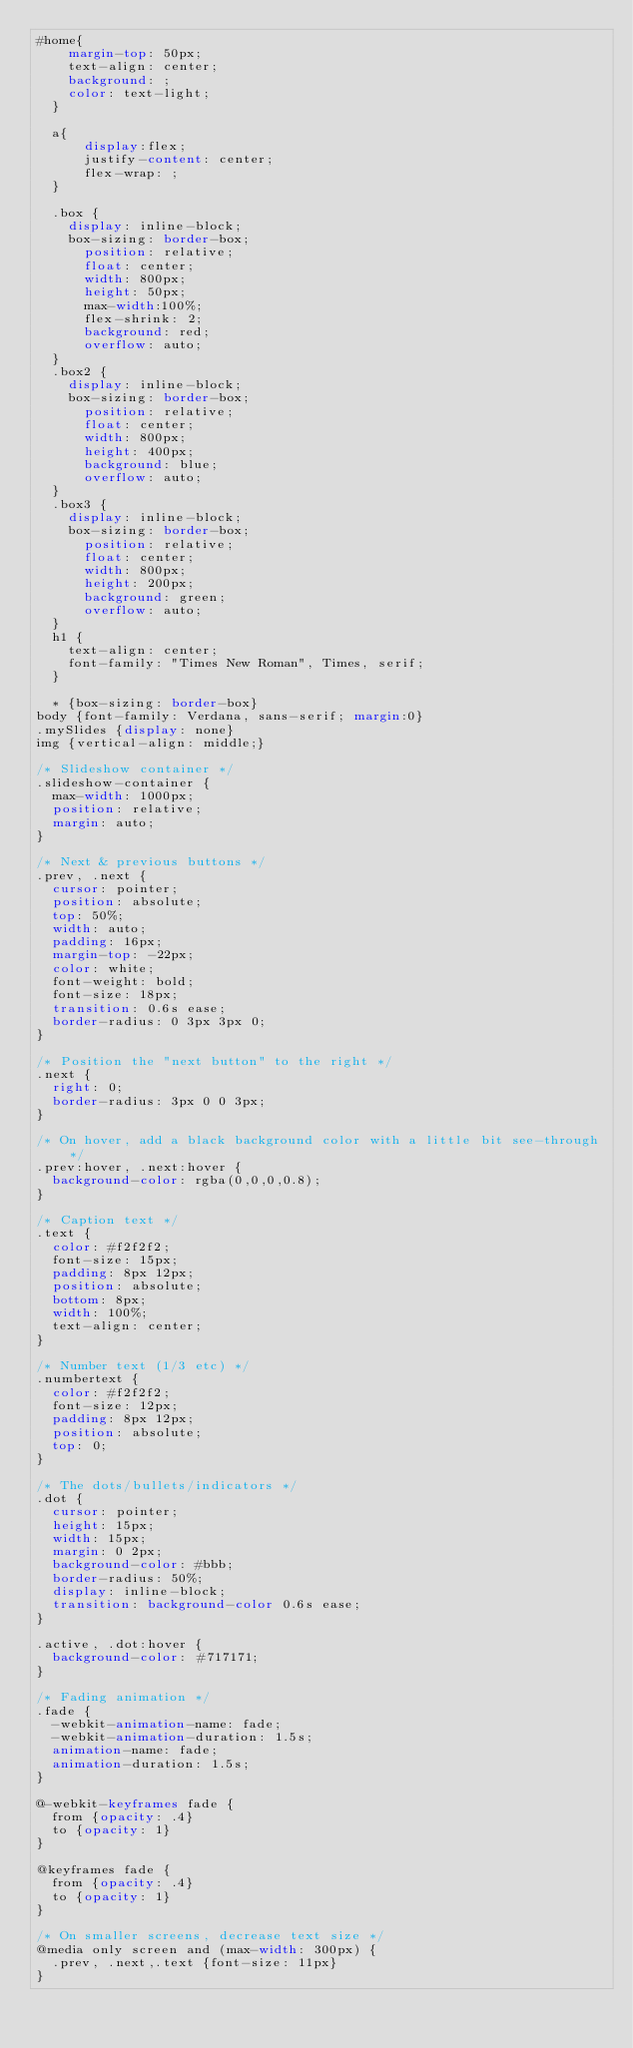Convert code to text. <code><loc_0><loc_0><loc_500><loc_500><_CSS_>#home{
    margin-top: 50px;
    text-align: center;
    background: ;
    color: text-light;
  }
  
  a{
      display:flex;
      justify-content: center;
      flex-wrap: ;
  }
  
  .box {
    display: inline-block;
    box-sizing: border-box;
      position: relative;
      float: center;
      width: 800px;
      height: 50px;
      max-width:100%;
      flex-shrink: 2;
      background: red; 
      overflow: auto;
  }
  .box2 {
    display: inline-block;
    box-sizing: border-box;
      position: relative;
      float: center;
      width: 800px;
      height: 400px;
      background: blue; 
      overflow: auto;
  }
  .box3 {
    display: inline-block;
    box-sizing: border-box;
      position: relative;
      float: center;
      width: 800px;
      height: 200px;
      background: green;
      overflow: auto;
  }
  h1 {
    text-align: center;
    font-family: "Times New Roman", Times, serif;
  }
  
  * {box-sizing: border-box}
body {font-family: Verdana, sans-serif; margin:0}
.mySlides {display: none}
img {vertical-align: middle;}

/* Slideshow container */
.slideshow-container {
  max-width: 1000px;
  position: relative;
  margin: auto;
}

/* Next & previous buttons */
.prev, .next {
  cursor: pointer;
  position: absolute;
  top: 50%;
  width: auto;
  padding: 16px;
  margin-top: -22px;
  color: white;
  font-weight: bold;
  font-size: 18px;
  transition: 0.6s ease;
  border-radius: 0 3px 3px 0;
}

/* Position the "next button" to the right */
.next {
  right: 0;
  border-radius: 3px 0 0 3px;
}

/* On hover, add a black background color with a little bit see-through */
.prev:hover, .next:hover {
  background-color: rgba(0,0,0,0.8);
}

/* Caption text */
.text {
  color: #f2f2f2;
  font-size: 15px;
  padding: 8px 12px;
  position: absolute;
  bottom: 8px;
  width: 100%;
  text-align: center;
}

/* Number text (1/3 etc) */
.numbertext {
  color: #f2f2f2;
  font-size: 12px;
  padding: 8px 12px;
  position: absolute;
  top: 0;
}

/* The dots/bullets/indicators */
.dot {
  cursor: pointer;
  height: 15px;
  width: 15px;
  margin: 0 2px;
  background-color: #bbb;
  border-radius: 50%;
  display: inline-block;
  transition: background-color 0.6s ease;
}

.active, .dot:hover {
  background-color: #717171;
}

/* Fading animation */
.fade {
  -webkit-animation-name: fade;
  -webkit-animation-duration: 1.5s;
  animation-name: fade;
  animation-duration: 1.5s;
}

@-webkit-keyframes fade {
  from {opacity: .4} 
  to {opacity: 1}
}

@keyframes fade {
  from {opacity: .4} 
  to {opacity: 1}
}

/* On smaller screens, decrease text size */
@media only screen and (max-width: 300px) {
  .prev, .next,.text {font-size: 11px}
}</code> 